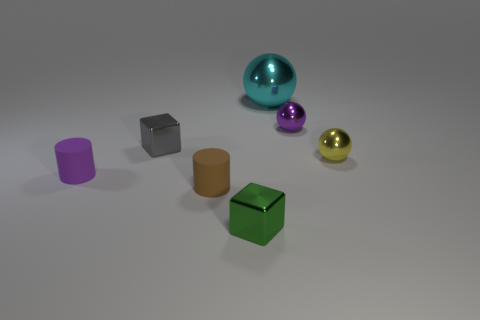Add 2 brown matte objects. How many objects exist? 9 Subtract all tiny metallic spheres. How many spheres are left? 1 Subtract 1 spheres. How many spheres are left? 2 Subtract all cylinders. How many objects are left? 5 Add 5 small yellow cylinders. How many small yellow cylinders exist? 5 Subtract 0 red balls. How many objects are left? 7 Subtract all green balls. Subtract all purple cubes. How many balls are left? 3 Subtract all tiny yellow rubber things. Subtract all brown rubber objects. How many objects are left? 6 Add 5 small purple metallic spheres. How many small purple metallic spheres are left? 6 